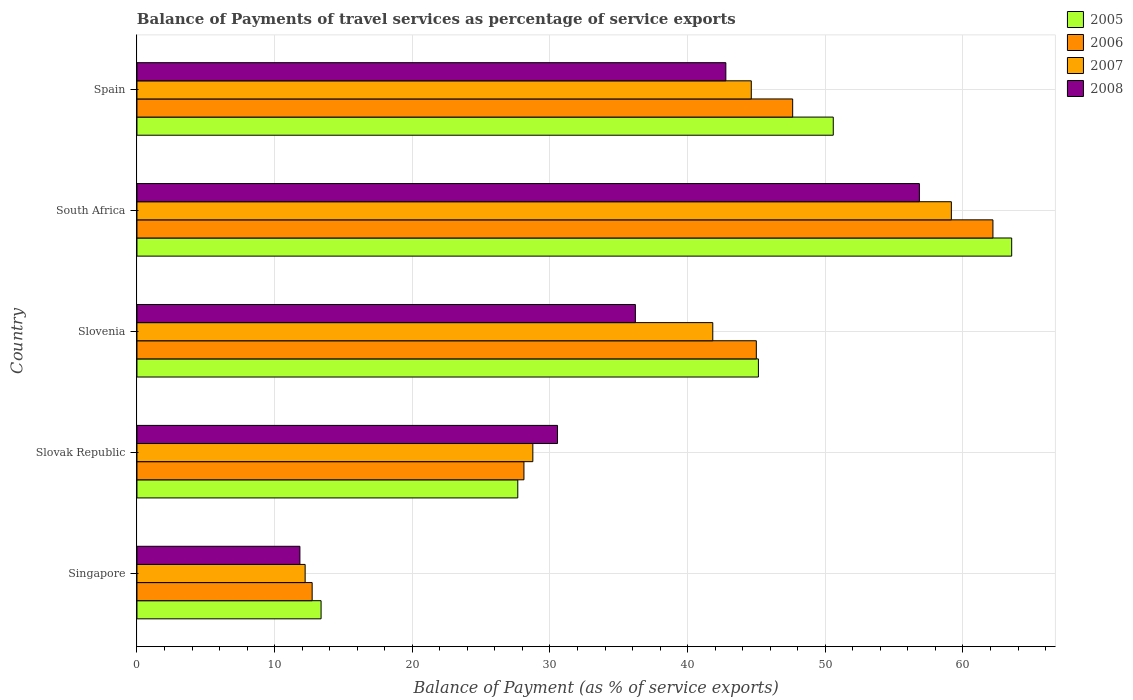Are the number of bars per tick equal to the number of legend labels?
Ensure brevity in your answer.  Yes. Are the number of bars on each tick of the Y-axis equal?
Give a very brief answer. Yes. What is the label of the 5th group of bars from the top?
Provide a succinct answer. Singapore. What is the balance of payments of travel services in 2007 in South Africa?
Provide a short and direct response. 59.16. Across all countries, what is the maximum balance of payments of travel services in 2008?
Offer a terse response. 56.83. Across all countries, what is the minimum balance of payments of travel services in 2008?
Make the answer very short. 11.84. In which country was the balance of payments of travel services in 2005 maximum?
Your response must be concise. South Africa. In which country was the balance of payments of travel services in 2007 minimum?
Offer a terse response. Singapore. What is the total balance of payments of travel services in 2007 in the graph?
Provide a succinct answer. 186.58. What is the difference between the balance of payments of travel services in 2007 in Slovak Republic and that in Spain?
Your answer should be very brief. -15.87. What is the difference between the balance of payments of travel services in 2005 in Slovenia and the balance of payments of travel services in 2006 in Spain?
Make the answer very short. -2.49. What is the average balance of payments of travel services in 2008 per country?
Provide a succinct answer. 35.64. What is the difference between the balance of payments of travel services in 2006 and balance of payments of travel services in 2005 in Slovenia?
Offer a terse response. -0.15. In how many countries, is the balance of payments of travel services in 2006 greater than 62 %?
Your answer should be very brief. 1. What is the ratio of the balance of payments of travel services in 2008 in Singapore to that in Spain?
Offer a terse response. 0.28. Is the balance of payments of travel services in 2005 in Singapore less than that in Slovak Republic?
Provide a succinct answer. Yes. What is the difference between the highest and the second highest balance of payments of travel services in 2006?
Your response must be concise. 14.55. What is the difference between the highest and the lowest balance of payments of travel services in 2008?
Your answer should be very brief. 45. In how many countries, is the balance of payments of travel services in 2008 greater than the average balance of payments of travel services in 2008 taken over all countries?
Provide a succinct answer. 3. What does the 1st bar from the top in Singapore represents?
Provide a succinct answer. 2008. Are all the bars in the graph horizontal?
Your response must be concise. Yes. Does the graph contain any zero values?
Your response must be concise. No. Where does the legend appear in the graph?
Provide a succinct answer. Top right. How are the legend labels stacked?
Your response must be concise. Vertical. What is the title of the graph?
Provide a succinct answer. Balance of Payments of travel services as percentage of service exports. Does "1996" appear as one of the legend labels in the graph?
Keep it short and to the point. No. What is the label or title of the X-axis?
Make the answer very short. Balance of Payment (as % of service exports). What is the label or title of the Y-axis?
Make the answer very short. Country. What is the Balance of Payment (as % of service exports) in 2005 in Singapore?
Your response must be concise. 13.37. What is the Balance of Payment (as % of service exports) of 2006 in Singapore?
Make the answer very short. 12.73. What is the Balance of Payment (as % of service exports) in 2007 in Singapore?
Offer a very short reply. 12.22. What is the Balance of Payment (as % of service exports) of 2008 in Singapore?
Provide a short and direct response. 11.84. What is the Balance of Payment (as % of service exports) of 2005 in Slovak Republic?
Your answer should be compact. 27.66. What is the Balance of Payment (as % of service exports) in 2006 in Slovak Republic?
Give a very brief answer. 28.11. What is the Balance of Payment (as % of service exports) of 2007 in Slovak Republic?
Your answer should be compact. 28.76. What is the Balance of Payment (as % of service exports) in 2008 in Slovak Republic?
Your response must be concise. 30.55. What is the Balance of Payment (as % of service exports) in 2005 in Slovenia?
Provide a succinct answer. 45.14. What is the Balance of Payment (as % of service exports) of 2006 in Slovenia?
Ensure brevity in your answer.  44.99. What is the Balance of Payment (as % of service exports) of 2007 in Slovenia?
Provide a succinct answer. 41.83. What is the Balance of Payment (as % of service exports) of 2008 in Slovenia?
Provide a short and direct response. 36.2. What is the Balance of Payment (as % of service exports) of 2005 in South Africa?
Ensure brevity in your answer.  63.54. What is the Balance of Payment (as % of service exports) of 2006 in South Africa?
Offer a very short reply. 62.18. What is the Balance of Payment (as % of service exports) of 2007 in South Africa?
Give a very brief answer. 59.16. What is the Balance of Payment (as % of service exports) in 2008 in South Africa?
Offer a very short reply. 56.83. What is the Balance of Payment (as % of service exports) in 2005 in Spain?
Give a very brief answer. 50.58. What is the Balance of Payment (as % of service exports) in 2006 in Spain?
Make the answer very short. 47.63. What is the Balance of Payment (as % of service exports) of 2007 in Spain?
Offer a terse response. 44.62. What is the Balance of Payment (as % of service exports) in 2008 in Spain?
Offer a terse response. 42.78. Across all countries, what is the maximum Balance of Payment (as % of service exports) of 2005?
Your answer should be very brief. 63.54. Across all countries, what is the maximum Balance of Payment (as % of service exports) of 2006?
Offer a terse response. 62.18. Across all countries, what is the maximum Balance of Payment (as % of service exports) in 2007?
Your answer should be very brief. 59.16. Across all countries, what is the maximum Balance of Payment (as % of service exports) of 2008?
Make the answer very short. 56.83. Across all countries, what is the minimum Balance of Payment (as % of service exports) in 2005?
Make the answer very short. 13.37. Across all countries, what is the minimum Balance of Payment (as % of service exports) of 2006?
Make the answer very short. 12.73. Across all countries, what is the minimum Balance of Payment (as % of service exports) in 2007?
Make the answer very short. 12.22. Across all countries, what is the minimum Balance of Payment (as % of service exports) of 2008?
Your answer should be compact. 11.84. What is the total Balance of Payment (as % of service exports) of 2005 in the graph?
Give a very brief answer. 200.3. What is the total Balance of Payment (as % of service exports) in 2006 in the graph?
Your response must be concise. 195.63. What is the total Balance of Payment (as % of service exports) of 2007 in the graph?
Your response must be concise. 186.58. What is the total Balance of Payment (as % of service exports) in 2008 in the graph?
Give a very brief answer. 178.2. What is the difference between the Balance of Payment (as % of service exports) in 2005 in Singapore and that in Slovak Republic?
Give a very brief answer. -14.29. What is the difference between the Balance of Payment (as % of service exports) in 2006 in Singapore and that in Slovak Republic?
Offer a terse response. -15.38. What is the difference between the Balance of Payment (as % of service exports) in 2007 in Singapore and that in Slovak Republic?
Give a very brief answer. -16.54. What is the difference between the Balance of Payment (as % of service exports) in 2008 in Singapore and that in Slovak Republic?
Ensure brevity in your answer.  -18.71. What is the difference between the Balance of Payment (as % of service exports) in 2005 in Singapore and that in Slovenia?
Give a very brief answer. -31.77. What is the difference between the Balance of Payment (as % of service exports) of 2006 in Singapore and that in Slovenia?
Give a very brief answer. -32.26. What is the difference between the Balance of Payment (as % of service exports) in 2007 in Singapore and that in Slovenia?
Give a very brief answer. -29.61. What is the difference between the Balance of Payment (as % of service exports) in 2008 in Singapore and that in Slovenia?
Keep it short and to the point. -24.37. What is the difference between the Balance of Payment (as % of service exports) of 2005 in Singapore and that in South Africa?
Your answer should be very brief. -50.17. What is the difference between the Balance of Payment (as % of service exports) in 2006 in Singapore and that in South Africa?
Your answer should be compact. -49.45. What is the difference between the Balance of Payment (as % of service exports) of 2007 in Singapore and that in South Africa?
Ensure brevity in your answer.  -46.94. What is the difference between the Balance of Payment (as % of service exports) in 2008 in Singapore and that in South Africa?
Give a very brief answer. -45. What is the difference between the Balance of Payment (as % of service exports) in 2005 in Singapore and that in Spain?
Your response must be concise. -37.21. What is the difference between the Balance of Payment (as % of service exports) in 2006 in Singapore and that in Spain?
Your answer should be very brief. -34.91. What is the difference between the Balance of Payment (as % of service exports) of 2007 in Singapore and that in Spain?
Make the answer very short. -32.41. What is the difference between the Balance of Payment (as % of service exports) of 2008 in Singapore and that in Spain?
Give a very brief answer. -30.94. What is the difference between the Balance of Payment (as % of service exports) of 2005 in Slovak Republic and that in Slovenia?
Keep it short and to the point. -17.48. What is the difference between the Balance of Payment (as % of service exports) in 2006 in Slovak Republic and that in Slovenia?
Offer a very short reply. -16.88. What is the difference between the Balance of Payment (as % of service exports) in 2007 in Slovak Republic and that in Slovenia?
Ensure brevity in your answer.  -13.07. What is the difference between the Balance of Payment (as % of service exports) in 2008 in Slovak Republic and that in Slovenia?
Offer a very short reply. -5.66. What is the difference between the Balance of Payment (as % of service exports) in 2005 in Slovak Republic and that in South Africa?
Offer a very short reply. -35.88. What is the difference between the Balance of Payment (as % of service exports) in 2006 in Slovak Republic and that in South Africa?
Provide a short and direct response. -34.07. What is the difference between the Balance of Payment (as % of service exports) in 2007 in Slovak Republic and that in South Africa?
Make the answer very short. -30.4. What is the difference between the Balance of Payment (as % of service exports) of 2008 in Slovak Republic and that in South Africa?
Provide a short and direct response. -26.29. What is the difference between the Balance of Payment (as % of service exports) of 2005 in Slovak Republic and that in Spain?
Your answer should be very brief. -22.92. What is the difference between the Balance of Payment (as % of service exports) in 2006 in Slovak Republic and that in Spain?
Provide a succinct answer. -19.52. What is the difference between the Balance of Payment (as % of service exports) of 2007 in Slovak Republic and that in Spain?
Offer a terse response. -15.87. What is the difference between the Balance of Payment (as % of service exports) in 2008 in Slovak Republic and that in Spain?
Your answer should be compact. -12.23. What is the difference between the Balance of Payment (as % of service exports) of 2005 in Slovenia and that in South Africa?
Offer a very short reply. -18.4. What is the difference between the Balance of Payment (as % of service exports) in 2006 in Slovenia and that in South Africa?
Provide a short and direct response. -17.19. What is the difference between the Balance of Payment (as % of service exports) of 2007 in Slovenia and that in South Africa?
Your answer should be compact. -17.33. What is the difference between the Balance of Payment (as % of service exports) in 2008 in Slovenia and that in South Africa?
Make the answer very short. -20.63. What is the difference between the Balance of Payment (as % of service exports) of 2005 in Slovenia and that in Spain?
Offer a terse response. -5.44. What is the difference between the Balance of Payment (as % of service exports) in 2006 in Slovenia and that in Spain?
Provide a short and direct response. -2.64. What is the difference between the Balance of Payment (as % of service exports) in 2007 in Slovenia and that in Spain?
Provide a short and direct response. -2.8. What is the difference between the Balance of Payment (as % of service exports) of 2008 in Slovenia and that in Spain?
Provide a succinct answer. -6.57. What is the difference between the Balance of Payment (as % of service exports) of 2005 in South Africa and that in Spain?
Provide a succinct answer. 12.96. What is the difference between the Balance of Payment (as % of service exports) of 2006 in South Africa and that in Spain?
Your response must be concise. 14.55. What is the difference between the Balance of Payment (as % of service exports) of 2007 in South Africa and that in Spain?
Provide a succinct answer. 14.53. What is the difference between the Balance of Payment (as % of service exports) of 2008 in South Africa and that in Spain?
Make the answer very short. 14.06. What is the difference between the Balance of Payment (as % of service exports) of 2005 in Singapore and the Balance of Payment (as % of service exports) of 2006 in Slovak Republic?
Ensure brevity in your answer.  -14.74. What is the difference between the Balance of Payment (as % of service exports) in 2005 in Singapore and the Balance of Payment (as % of service exports) in 2007 in Slovak Republic?
Keep it short and to the point. -15.38. What is the difference between the Balance of Payment (as % of service exports) of 2005 in Singapore and the Balance of Payment (as % of service exports) of 2008 in Slovak Republic?
Your answer should be compact. -17.18. What is the difference between the Balance of Payment (as % of service exports) in 2006 in Singapore and the Balance of Payment (as % of service exports) in 2007 in Slovak Republic?
Your response must be concise. -16.03. What is the difference between the Balance of Payment (as % of service exports) in 2006 in Singapore and the Balance of Payment (as % of service exports) in 2008 in Slovak Republic?
Offer a terse response. -17.82. What is the difference between the Balance of Payment (as % of service exports) in 2007 in Singapore and the Balance of Payment (as % of service exports) in 2008 in Slovak Republic?
Make the answer very short. -18.33. What is the difference between the Balance of Payment (as % of service exports) in 2005 in Singapore and the Balance of Payment (as % of service exports) in 2006 in Slovenia?
Offer a very short reply. -31.62. What is the difference between the Balance of Payment (as % of service exports) of 2005 in Singapore and the Balance of Payment (as % of service exports) of 2007 in Slovenia?
Your answer should be very brief. -28.45. What is the difference between the Balance of Payment (as % of service exports) in 2005 in Singapore and the Balance of Payment (as % of service exports) in 2008 in Slovenia?
Offer a very short reply. -22.83. What is the difference between the Balance of Payment (as % of service exports) of 2006 in Singapore and the Balance of Payment (as % of service exports) of 2007 in Slovenia?
Offer a terse response. -29.1. What is the difference between the Balance of Payment (as % of service exports) of 2006 in Singapore and the Balance of Payment (as % of service exports) of 2008 in Slovenia?
Keep it short and to the point. -23.48. What is the difference between the Balance of Payment (as % of service exports) in 2007 in Singapore and the Balance of Payment (as % of service exports) in 2008 in Slovenia?
Give a very brief answer. -23.99. What is the difference between the Balance of Payment (as % of service exports) of 2005 in Singapore and the Balance of Payment (as % of service exports) of 2006 in South Africa?
Ensure brevity in your answer.  -48.8. What is the difference between the Balance of Payment (as % of service exports) in 2005 in Singapore and the Balance of Payment (as % of service exports) in 2007 in South Africa?
Keep it short and to the point. -45.78. What is the difference between the Balance of Payment (as % of service exports) in 2005 in Singapore and the Balance of Payment (as % of service exports) in 2008 in South Africa?
Make the answer very short. -43.46. What is the difference between the Balance of Payment (as % of service exports) in 2006 in Singapore and the Balance of Payment (as % of service exports) in 2007 in South Africa?
Make the answer very short. -46.43. What is the difference between the Balance of Payment (as % of service exports) in 2006 in Singapore and the Balance of Payment (as % of service exports) in 2008 in South Africa?
Your answer should be compact. -44.11. What is the difference between the Balance of Payment (as % of service exports) of 2007 in Singapore and the Balance of Payment (as % of service exports) of 2008 in South Africa?
Your response must be concise. -44.62. What is the difference between the Balance of Payment (as % of service exports) in 2005 in Singapore and the Balance of Payment (as % of service exports) in 2006 in Spain?
Ensure brevity in your answer.  -34.26. What is the difference between the Balance of Payment (as % of service exports) of 2005 in Singapore and the Balance of Payment (as % of service exports) of 2007 in Spain?
Ensure brevity in your answer.  -31.25. What is the difference between the Balance of Payment (as % of service exports) of 2005 in Singapore and the Balance of Payment (as % of service exports) of 2008 in Spain?
Give a very brief answer. -29.4. What is the difference between the Balance of Payment (as % of service exports) of 2006 in Singapore and the Balance of Payment (as % of service exports) of 2007 in Spain?
Provide a succinct answer. -31.9. What is the difference between the Balance of Payment (as % of service exports) in 2006 in Singapore and the Balance of Payment (as % of service exports) in 2008 in Spain?
Ensure brevity in your answer.  -30.05. What is the difference between the Balance of Payment (as % of service exports) of 2007 in Singapore and the Balance of Payment (as % of service exports) of 2008 in Spain?
Offer a very short reply. -30.56. What is the difference between the Balance of Payment (as % of service exports) in 2005 in Slovak Republic and the Balance of Payment (as % of service exports) in 2006 in Slovenia?
Provide a succinct answer. -17.33. What is the difference between the Balance of Payment (as % of service exports) of 2005 in Slovak Republic and the Balance of Payment (as % of service exports) of 2007 in Slovenia?
Offer a very short reply. -14.16. What is the difference between the Balance of Payment (as % of service exports) in 2005 in Slovak Republic and the Balance of Payment (as % of service exports) in 2008 in Slovenia?
Make the answer very short. -8.54. What is the difference between the Balance of Payment (as % of service exports) in 2006 in Slovak Republic and the Balance of Payment (as % of service exports) in 2007 in Slovenia?
Your answer should be compact. -13.72. What is the difference between the Balance of Payment (as % of service exports) in 2006 in Slovak Republic and the Balance of Payment (as % of service exports) in 2008 in Slovenia?
Ensure brevity in your answer.  -8.1. What is the difference between the Balance of Payment (as % of service exports) of 2007 in Slovak Republic and the Balance of Payment (as % of service exports) of 2008 in Slovenia?
Your response must be concise. -7.45. What is the difference between the Balance of Payment (as % of service exports) in 2005 in Slovak Republic and the Balance of Payment (as % of service exports) in 2006 in South Africa?
Make the answer very short. -34.52. What is the difference between the Balance of Payment (as % of service exports) in 2005 in Slovak Republic and the Balance of Payment (as % of service exports) in 2007 in South Africa?
Provide a short and direct response. -31.5. What is the difference between the Balance of Payment (as % of service exports) of 2005 in Slovak Republic and the Balance of Payment (as % of service exports) of 2008 in South Africa?
Provide a succinct answer. -29.17. What is the difference between the Balance of Payment (as % of service exports) of 2006 in Slovak Republic and the Balance of Payment (as % of service exports) of 2007 in South Africa?
Offer a very short reply. -31.05. What is the difference between the Balance of Payment (as % of service exports) in 2006 in Slovak Republic and the Balance of Payment (as % of service exports) in 2008 in South Africa?
Your answer should be compact. -28.73. What is the difference between the Balance of Payment (as % of service exports) in 2007 in Slovak Republic and the Balance of Payment (as % of service exports) in 2008 in South Africa?
Provide a short and direct response. -28.08. What is the difference between the Balance of Payment (as % of service exports) of 2005 in Slovak Republic and the Balance of Payment (as % of service exports) of 2006 in Spain?
Ensure brevity in your answer.  -19.97. What is the difference between the Balance of Payment (as % of service exports) of 2005 in Slovak Republic and the Balance of Payment (as % of service exports) of 2007 in Spain?
Make the answer very short. -16.96. What is the difference between the Balance of Payment (as % of service exports) of 2005 in Slovak Republic and the Balance of Payment (as % of service exports) of 2008 in Spain?
Keep it short and to the point. -15.11. What is the difference between the Balance of Payment (as % of service exports) of 2006 in Slovak Republic and the Balance of Payment (as % of service exports) of 2007 in Spain?
Offer a terse response. -16.51. What is the difference between the Balance of Payment (as % of service exports) in 2006 in Slovak Republic and the Balance of Payment (as % of service exports) in 2008 in Spain?
Give a very brief answer. -14.67. What is the difference between the Balance of Payment (as % of service exports) of 2007 in Slovak Republic and the Balance of Payment (as % of service exports) of 2008 in Spain?
Your answer should be compact. -14.02. What is the difference between the Balance of Payment (as % of service exports) of 2005 in Slovenia and the Balance of Payment (as % of service exports) of 2006 in South Africa?
Provide a short and direct response. -17.04. What is the difference between the Balance of Payment (as % of service exports) of 2005 in Slovenia and the Balance of Payment (as % of service exports) of 2007 in South Africa?
Keep it short and to the point. -14.02. What is the difference between the Balance of Payment (as % of service exports) of 2005 in Slovenia and the Balance of Payment (as % of service exports) of 2008 in South Africa?
Provide a succinct answer. -11.69. What is the difference between the Balance of Payment (as % of service exports) in 2006 in Slovenia and the Balance of Payment (as % of service exports) in 2007 in South Africa?
Give a very brief answer. -14.17. What is the difference between the Balance of Payment (as % of service exports) of 2006 in Slovenia and the Balance of Payment (as % of service exports) of 2008 in South Africa?
Provide a succinct answer. -11.84. What is the difference between the Balance of Payment (as % of service exports) in 2007 in Slovenia and the Balance of Payment (as % of service exports) in 2008 in South Africa?
Provide a succinct answer. -15.01. What is the difference between the Balance of Payment (as % of service exports) in 2005 in Slovenia and the Balance of Payment (as % of service exports) in 2006 in Spain?
Keep it short and to the point. -2.49. What is the difference between the Balance of Payment (as % of service exports) of 2005 in Slovenia and the Balance of Payment (as % of service exports) of 2007 in Spain?
Your response must be concise. 0.52. What is the difference between the Balance of Payment (as % of service exports) of 2005 in Slovenia and the Balance of Payment (as % of service exports) of 2008 in Spain?
Your response must be concise. 2.37. What is the difference between the Balance of Payment (as % of service exports) in 2006 in Slovenia and the Balance of Payment (as % of service exports) in 2007 in Spain?
Provide a short and direct response. 0.37. What is the difference between the Balance of Payment (as % of service exports) of 2006 in Slovenia and the Balance of Payment (as % of service exports) of 2008 in Spain?
Your answer should be compact. 2.21. What is the difference between the Balance of Payment (as % of service exports) in 2007 in Slovenia and the Balance of Payment (as % of service exports) in 2008 in Spain?
Keep it short and to the point. -0.95. What is the difference between the Balance of Payment (as % of service exports) of 2005 in South Africa and the Balance of Payment (as % of service exports) of 2006 in Spain?
Make the answer very short. 15.91. What is the difference between the Balance of Payment (as % of service exports) of 2005 in South Africa and the Balance of Payment (as % of service exports) of 2007 in Spain?
Offer a very short reply. 18.92. What is the difference between the Balance of Payment (as % of service exports) of 2005 in South Africa and the Balance of Payment (as % of service exports) of 2008 in Spain?
Your response must be concise. 20.76. What is the difference between the Balance of Payment (as % of service exports) in 2006 in South Africa and the Balance of Payment (as % of service exports) in 2007 in Spain?
Provide a short and direct response. 17.55. What is the difference between the Balance of Payment (as % of service exports) of 2006 in South Africa and the Balance of Payment (as % of service exports) of 2008 in Spain?
Ensure brevity in your answer.  19.4. What is the difference between the Balance of Payment (as % of service exports) of 2007 in South Africa and the Balance of Payment (as % of service exports) of 2008 in Spain?
Give a very brief answer. 16.38. What is the average Balance of Payment (as % of service exports) in 2005 per country?
Provide a succinct answer. 40.06. What is the average Balance of Payment (as % of service exports) of 2006 per country?
Provide a short and direct response. 39.13. What is the average Balance of Payment (as % of service exports) in 2007 per country?
Provide a short and direct response. 37.32. What is the average Balance of Payment (as % of service exports) of 2008 per country?
Offer a terse response. 35.64. What is the difference between the Balance of Payment (as % of service exports) of 2005 and Balance of Payment (as % of service exports) of 2006 in Singapore?
Your answer should be compact. 0.65. What is the difference between the Balance of Payment (as % of service exports) in 2005 and Balance of Payment (as % of service exports) in 2007 in Singapore?
Offer a very short reply. 1.16. What is the difference between the Balance of Payment (as % of service exports) of 2005 and Balance of Payment (as % of service exports) of 2008 in Singapore?
Your answer should be very brief. 1.54. What is the difference between the Balance of Payment (as % of service exports) of 2006 and Balance of Payment (as % of service exports) of 2007 in Singapore?
Offer a terse response. 0.51. What is the difference between the Balance of Payment (as % of service exports) of 2006 and Balance of Payment (as % of service exports) of 2008 in Singapore?
Ensure brevity in your answer.  0.89. What is the difference between the Balance of Payment (as % of service exports) of 2007 and Balance of Payment (as % of service exports) of 2008 in Singapore?
Keep it short and to the point. 0.38. What is the difference between the Balance of Payment (as % of service exports) of 2005 and Balance of Payment (as % of service exports) of 2006 in Slovak Republic?
Make the answer very short. -0.45. What is the difference between the Balance of Payment (as % of service exports) of 2005 and Balance of Payment (as % of service exports) of 2007 in Slovak Republic?
Offer a terse response. -1.1. What is the difference between the Balance of Payment (as % of service exports) in 2005 and Balance of Payment (as % of service exports) in 2008 in Slovak Republic?
Give a very brief answer. -2.89. What is the difference between the Balance of Payment (as % of service exports) of 2006 and Balance of Payment (as % of service exports) of 2007 in Slovak Republic?
Your response must be concise. -0.65. What is the difference between the Balance of Payment (as % of service exports) of 2006 and Balance of Payment (as % of service exports) of 2008 in Slovak Republic?
Your response must be concise. -2.44. What is the difference between the Balance of Payment (as % of service exports) in 2007 and Balance of Payment (as % of service exports) in 2008 in Slovak Republic?
Offer a very short reply. -1.79. What is the difference between the Balance of Payment (as % of service exports) in 2005 and Balance of Payment (as % of service exports) in 2006 in Slovenia?
Give a very brief answer. 0.15. What is the difference between the Balance of Payment (as % of service exports) of 2005 and Balance of Payment (as % of service exports) of 2007 in Slovenia?
Ensure brevity in your answer.  3.31. What is the difference between the Balance of Payment (as % of service exports) of 2005 and Balance of Payment (as % of service exports) of 2008 in Slovenia?
Your answer should be very brief. 8.94. What is the difference between the Balance of Payment (as % of service exports) of 2006 and Balance of Payment (as % of service exports) of 2007 in Slovenia?
Your answer should be compact. 3.16. What is the difference between the Balance of Payment (as % of service exports) of 2006 and Balance of Payment (as % of service exports) of 2008 in Slovenia?
Provide a short and direct response. 8.79. What is the difference between the Balance of Payment (as % of service exports) in 2007 and Balance of Payment (as % of service exports) in 2008 in Slovenia?
Provide a succinct answer. 5.62. What is the difference between the Balance of Payment (as % of service exports) of 2005 and Balance of Payment (as % of service exports) of 2006 in South Africa?
Ensure brevity in your answer.  1.36. What is the difference between the Balance of Payment (as % of service exports) of 2005 and Balance of Payment (as % of service exports) of 2007 in South Africa?
Your response must be concise. 4.38. What is the difference between the Balance of Payment (as % of service exports) in 2005 and Balance of Payment (as % of service exports) in 2008 in South Africa?
Your answer should be compact. 6.71. What is the difference between the Balance of Payment (as % of service exports) in 2006 and Balance of Payment (as % of service exports) in 2007 in South Africa?
Offer a very short reply. 3.02. What is the difference between the Balance of Payment (as % of service exports) in 2006 and Balance of Payment (as % of service exports) in 2008 in South Africa?
Provide a short and direct response. 5.34. What is the difference between the Balance of Payment (as % of service exports) in 2007 and Balance of Payment (as % of service exports) in 2008 in South Africa?
Provide a short and direct response. 2.32. What is the difference between the Balance of Payment (as % of service exports) of 2005 and Balance of Payment (as % of service exports) of 2006 in Spain?
Keep it short and to the point. 2.95. What is the difference between the Balance of Payment (as % of service exports) of 2005 and Balance of Payment (as % of service exports) of 2007 in Spain?
Make the answer very short. 5.96. What is the difference between the Balance of Payment (as % of service exports) in 2005 and Balance of Payment (as % of service exports) in 2008 in Spain?
Provide a short and direct response. 7.8. What is the difference between the Balance of Payment (as % of service exports) in 2006 and Balance of Payment (as % of service exports) in 2007 in Spain?
Keep it short and to the point. 3.01. What is the difference between the Balance of Payment (as % of service exports) of 2006 and Balance of Payment (as % of service exports) of 2008 in Spain?
Your answer should be very brief. 4.86. What is the difference between the Balance of Payment (as % of service exports) in 2007 and Balance of Payment (as % of service exports) in 2008 in Spain?
Provide a succinct answer. 1.85. What is the ratio of the Balance of Payment (as % of service exports) in 2005 in Singapore to that in Slovak Republic?
Offer a terse response. 0.48. What is the ratio of the Balance of Payment (as % of service exports) in 2006 in Singapore to that in Slovak Republic?
Keep it short and to the point. 0.45. What is the ratio of the Balance of Payment (as % of service exports) of 2007 in Singapore to that in Slovak Republic?
Ensure brevity in your answer.  0.42. What is the ratio of the Balance of Payment (as % of service exports) in 2008 in Singapore to that in Slovak Republic?
Make the answer very short. 0.39. What is the ratio of the Balance of Payment (as % of service exports) in 2005 in Singapore to that in Slovenia?
Provide a succinct answer. 0.3. What is the ratio of the Balance of Payment (as % of service exports) in 2006 in Singapore to that in Slovenia?
Give a very brief answer. 0.28. What is the ratio of the Balance of Payment (as % of service exports) of 2007 in Singapore to that in Slovenia?
Keep it short and to the point. 0.29. What is the ratio of the Balance of Payment (as % of service exports) of 2008 in Singapore to that in Slovenia?
Provide a succinct answer. 0.33. What is the ratio of the Balance of Payment (as % of service exports) in 2005 in Singapore to that in South Africa?
Offer a terse response. 0.21. What is the ratio of the Balance of Payment (as % of service exports) in 2006 in Singapore to that in South Africa?
Your answer should be compact. 0.2. What is the ratio of the Balance of Payment (as % of service exports) in 2007 in Singapore to that in South Africa?
Your response must be concise. 0.21. What is the ratio of the Balance of Payment (as % of service exports) in 2008 in Singapore to that in South Africa?
Make the answer very short. 0.21. What is the ratio of the Balance of Payment (as % of service exports) of 2005 in Singapore to that in Spain?
Your answer should be compact. 0.26. What is the ratio of the Balance of Payment (as % of service exports) in 2006 in Singapore to that in Spain?
Give a very brief answer. 0.27. What is the ratio of the Balance of Payment (as % of service exports) in 2007 in Singapore to that in Spain?
Offer a terse response. 0.27. What is the ratio of the Balance of Payment (as % of service exports) of 2008 in Singapore to that in Spain?
Give a very brief answer. 0.28. What is the ratio of the Balance of Payment (as % of service exports) of 2005 in Slovak Republic to that in Slovenia?
Make the answer very short. 0.61. What is the ratio of the Balance of Payment (as % of service exports) in 2006 in Slovak Republic to that in Slovenia?
Offer a very short reply. 0.62. What is the ratio of the Balance of Payment (as % of service exports) in 2007 in Slovak Republic to that in Slovenia?
Make the answer very short. 0.69. What is the ratio of the Balance of Payment (as % of service exports) of 2008 in Slovak Republic to that in Slovenia?
Ensure brevity in your answer.  0.84. What is the ratio of the Balance of Payment (as % of service exports) of 2005 in Slovak Republic to that in South Africa?
Give a very brief answer. 0.44. What is the ratio of the Balance of Payment (as % of service exports) in 2006 in Slovak Republic to that in South Africa?
Keep it short and to the point. 0.45. What is the ratio of the Balance of Payment (as % of service exports) of 2007 in Slovak Republic to that in South Africa?
Provide a succinct answer. 0.49. What is the ratio of the Balance of Payment (as % of service exports) of 2008 in Slovak Republic to that in South Africa?
Your response must be concise. 0.54. What is the ratio of the Balance of Payment (as % of service exports) in 2005 in Slovak Republic to that in Spain?
Make the answer very short. 0.55. What is the ratio of the Balance of Payment (as % of service exports) in 2006 in Slovak Republic to that in Spain?
Your answer should be compact. 0.59. What is the ratio of the Balance of Payment (as % of service exports) of 2007 in Slovak Republic to that in Spain?
Offer a terse response. 0.64. What is the ratio of the Balance of Payment (as % of service exports) in 2008 in Slovak Republic to that in Spain?
Ensure brevity in your answer.  0.71. What is the ratio of the Balance of Payment (as % of service exports) of 2005 in Slovenia to that in South Africa?
Provide a succinct answer. 0.71. What is the ratio of the Balance of Payment (as % of service exports) in 2006 in Slovenia to that in South Africa?
Your answer should be very brief. 0.72. What is the ratio of the Balance of Payment (as % of service exports) in 2007 in Slovenia to that in South Africa?
Your answer should be compact. 0.71. What is the ratio of the Balance of Payment (as % of service exports) in 2008 in Slovenia to that in South Africa?
Your answer should be very brief. 0.64. What is the ratio of the Balance of Payment (as % of service exports) of 2005 in Slovenia to that in Spain?
Provide a succinct answer. 0.89. What is the ratio of the Balance of Payment (as % of service exports) of 2006 in Slovenia to that in Spain?
Keep it short and to the point. 0.94. What is the ratio of the Balance of Payment (as % of service exports) in 2007 in Slovenia to that in Spain?
Keep it short and to the point. 0.94. What is the ratio of the Balance of Payment (as % of service exports) of 2008 in Slovenia to that in Spain?
Offer a terse response. 0.85. What is the ratio of the Balance of Payment (as % of service exports) in 2005 in South Africa to that in Spain?
Make the answer very short. 1.26. What is the ratio of the Balance of Payment (as % of service exports) in 2006 in South Africa to that in Spain?
Offer a very short reply. 1.31. What is the ratio of the Balance of Payment (as % of service exports) in 2007 in South Africa to that in Spain?
Offer a very short reply. 1.33. What is the ratio of the Balance of Payment (as % of service exports) in 2008 in South Africa to that in Spain?
Give a very brief answer. 1.33. What is the difference between the highest and the second highest Balance of Payment (as % of service exports) in 2005?
Give a very brief answer. 12.96. What is the difference between the highest and the second highest Balance of Payment (as % of service exports) of 2006?
Your response must be concise. 14.55. What is the difference between the highest and the second highest Balance of Payment (as % of service exports) of 2007?
Keep it short and to the point. 14.53. What is the difference between the highest and the second highest Balance of Payment (as % of service exports) in 2008?
Your answer should be very brief. 14.06. What is the difference between the highest and the lowest Balance of Payment (as % of service exports) of 2005?
Provide a short and direct response. 50.17. What is the difference between the highest and the lowest Balance of Payment (as % of service exports) of 2006?
Give a very brief answer. 49.45. What is the difference between the highest and the lowest Balance of Payment (as % of service exports) in 2007?
Your answer should be very brief. 46.94. What is the difference between the highest and the lowest Balance of Payment (as % of service exports) of 2008?
Offer a terse response. 45. 